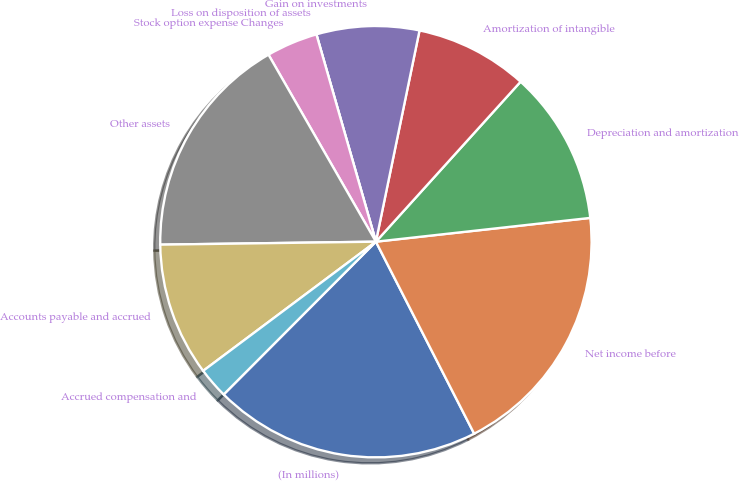<chart> <loc_0><loc_0><loc_500><loc_500><pie_chart><fcel>(In millions)<fcel>Net income before<fcel>Depreciation and amortization<fcel>Amortization of intangible<fcel>Gain on investments<fcel>Loss on disposition of assets<fcel>Stock option expense Changes<fcel>Other assets<fcel>Accounts payable and accrued<fcel>Accrued compensation and<nl><fcel>20.0%<fcel>19.23%<fcel>11.54%<fcel>8.46%<fcel>7.69%<fcel>0.0%<fcel>3.85%<fcel>16.92%<fcel>10.0%<fcel>2.31%<nl></chart> 